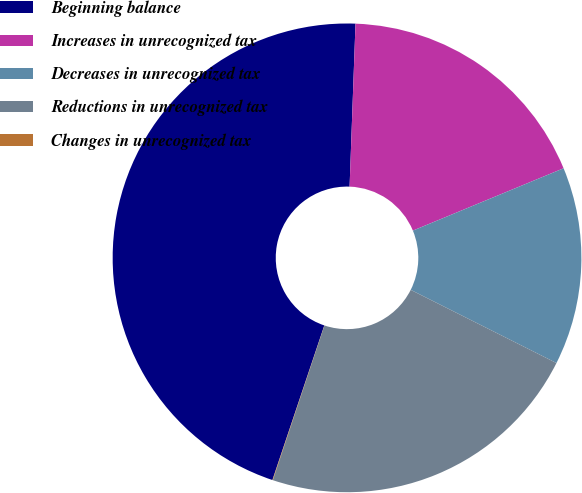Convert chart. <chart><loc_0><loc_0><loc_500><loc_500><pie_chart><fcel>Beginning balance<fcel>Increases in unrecognized tax<fcel>Decreases in unrecognized tax<fcel>Reductions in unrecognized tax<fcel>Changes in unrecognized tax<nl><fcel>45.42%<fcel>18.18%<fcel>13.65%<fcel>22.72%<fcel>0.03%<nl></chart> 